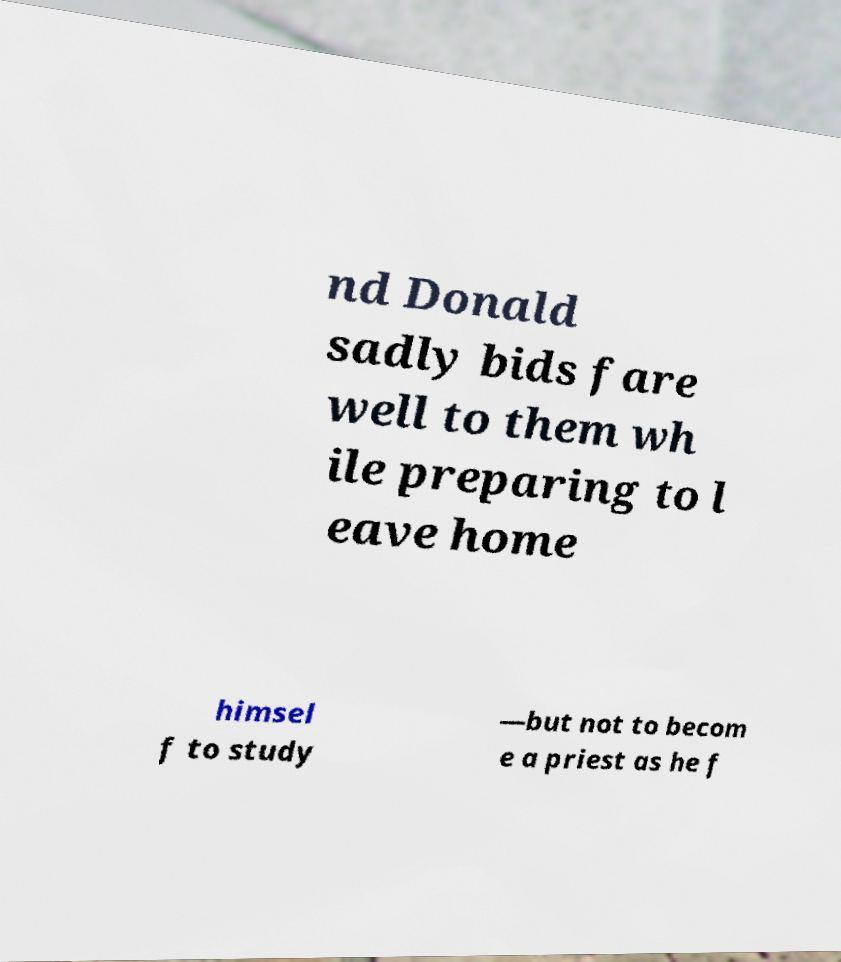Please read and relay the text visible in this image. What does it say? nd Donald sadly bids fare well to them wh ile preparing to l eave home himsel f to study —but not to becom e a priest as he f 